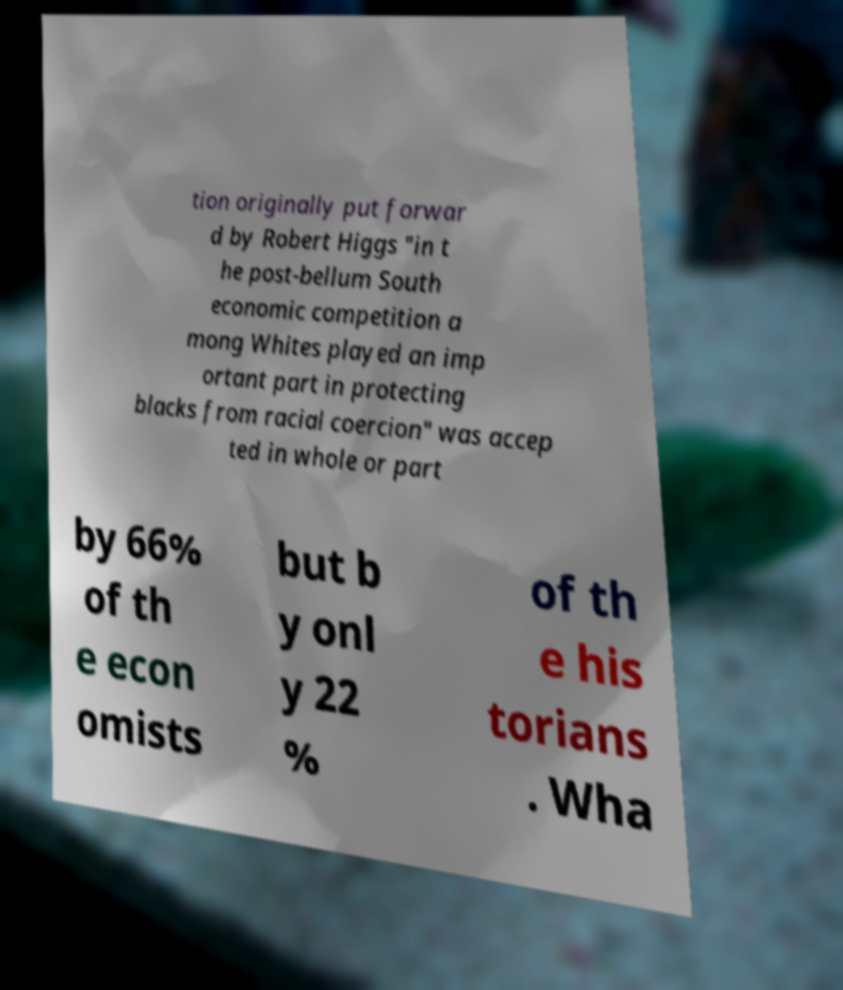Could you assist in decoding the text presented in this image and type it out clearly? tion originally put forwar d by Robert Higgs "in t he post-bellum South economic competition a mong Whites played an imp ortant part in protecting blacks from racial coercion" was accep ted in whole or part by 66% of th e econ omists but b y onl y 22 % of th e his torians . Wha 